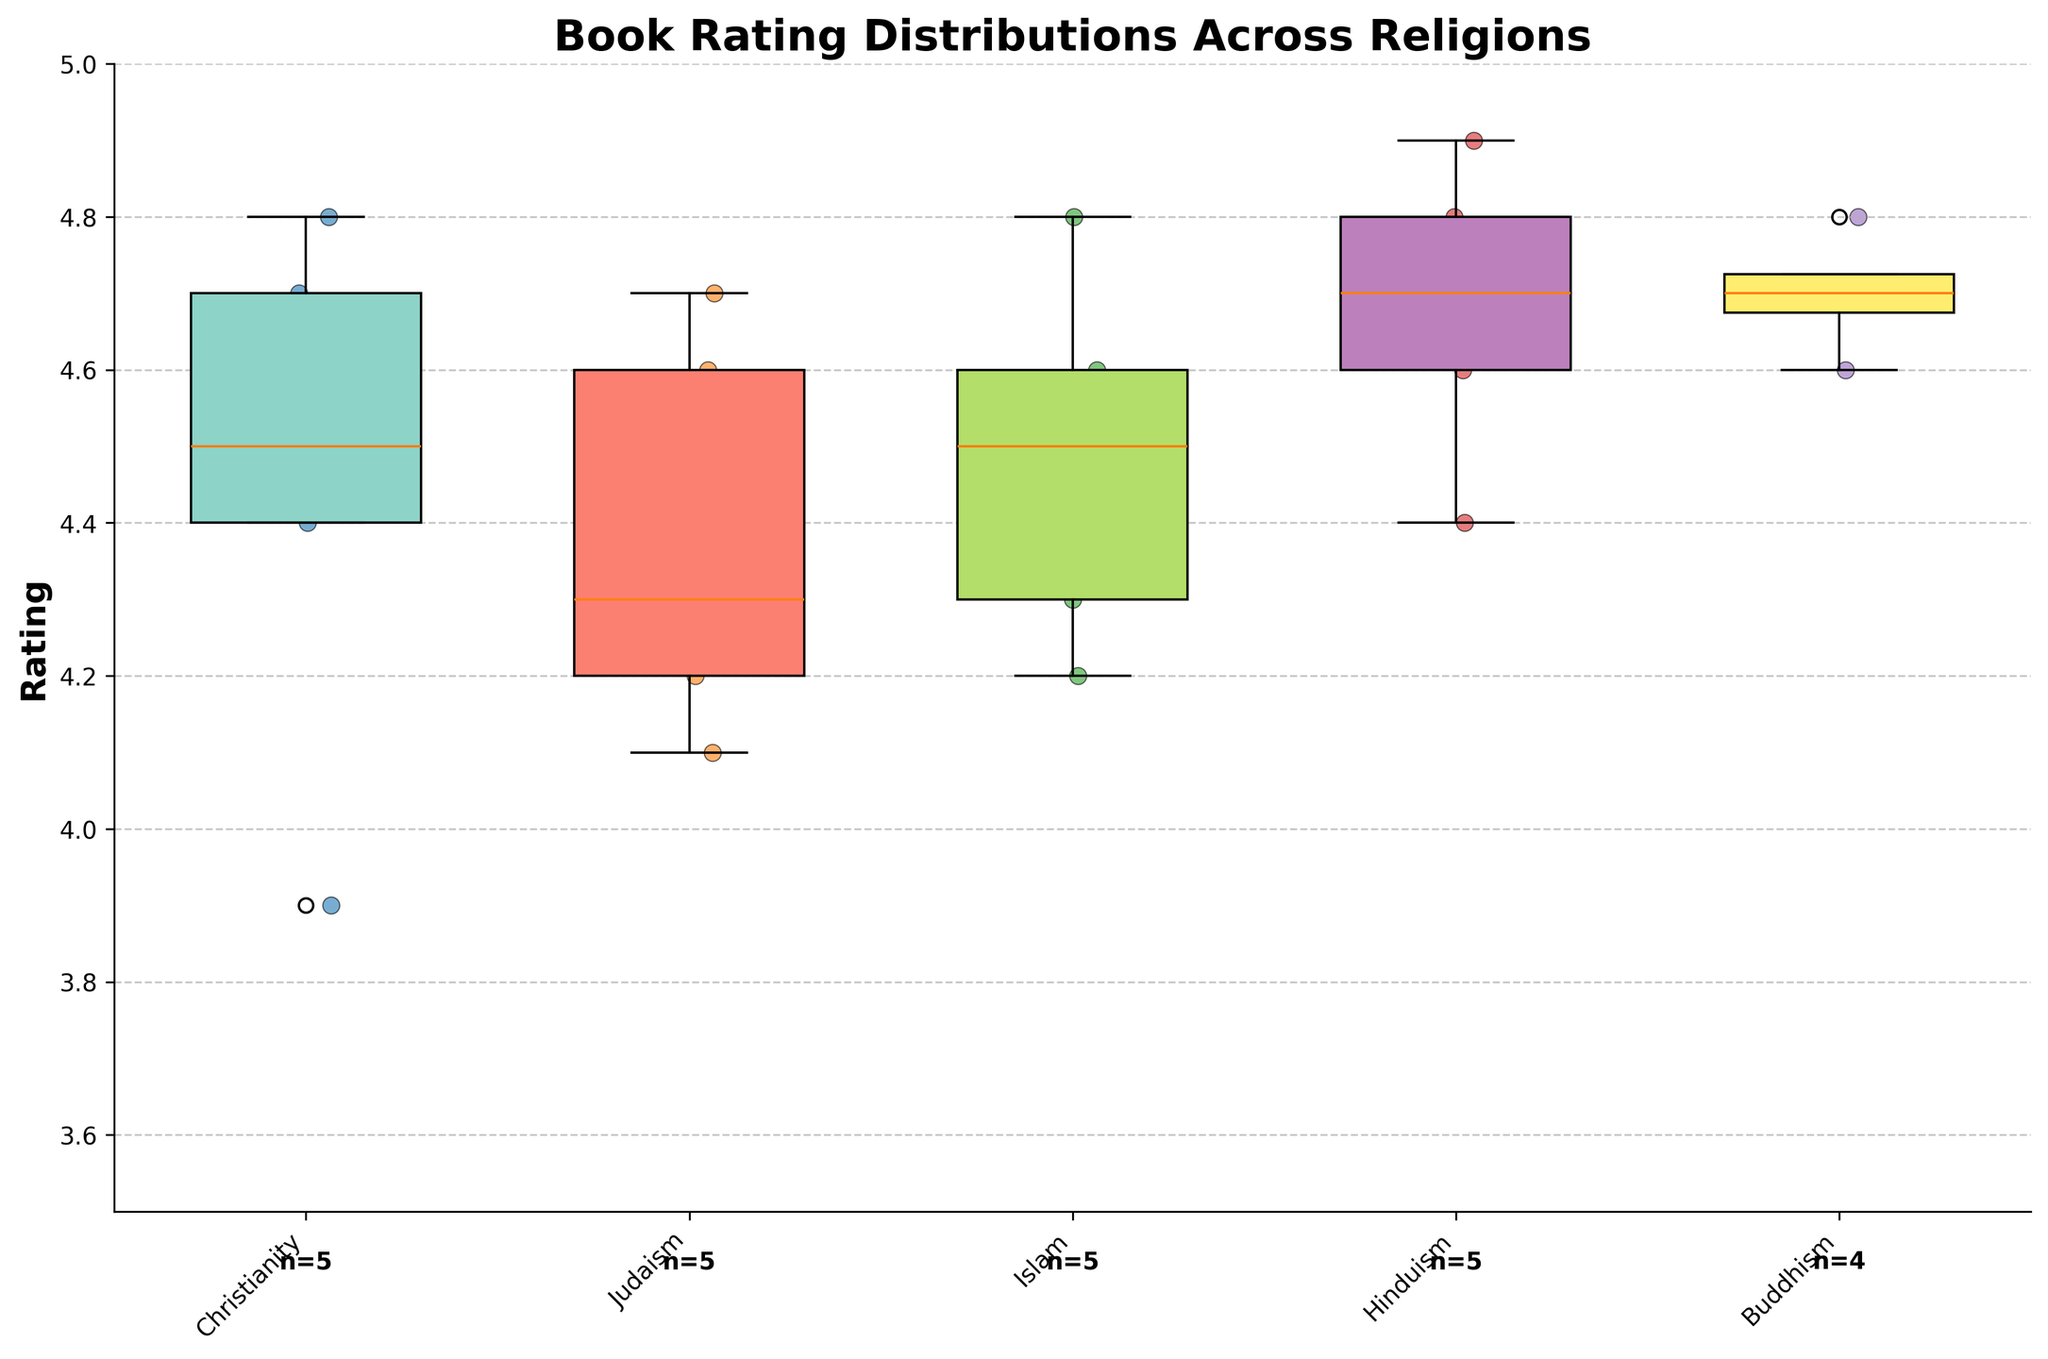How many different religions' book ratings are represented in the figure? The x-axis of the figure shows the different religions represented. Counting these religions will give us the number.
Answer: 5 Which religion has the highest median book rating? The median book rating is indicated by the line inside each box in the box plot. By comparing these lines, we can identify the religion with the highest median rating.
Answer: Hinduism What is the range of book ratings for Christianity? The range is found by noting the upper and lower whiskers of the box plot for Christianity. The range is the difference between these two values.
Answer: 4.8 - 3.9 How many books are rated from the Islamic religion? The count of data points for Islam is noted next to the label "Islam" near the x-axis. This number indicates how many books are rated.
Answer: 5 Which religions have at least one book rating above 4.6? Scatter points above 4.6 on the y-axis represent book ratings for different religions. Identifying these points and matching them to their respective religions will provide the answer.
Answer: Christianity, Judaism, Islam, Hinduism, Buddhism Which religion has the narrowest interquartile range (IQR) for its book ratings? The IQR is the distance between the top (Q3) and bottom (Q1) of the box in each box plot. By visually comparing the IQRs, we can determine the narrowest one.
Answer: Buddhism Compare the median book rating of Judaism with Buddhism. Which is higher? The median is represented by the line inside the boxes. By comparing the medians for Judaism and Buddhism, we can find which one is higher.
Answer: Both are equal Which religion has the highest variability in its book ratings and how can you tell? The variability in book ratings is indicated by the length of the whiskers and the spread of the scatter points. The longer the whiskers and wider the spread, the higher the variability.
Answer: Christianity What is the mean book rating for Hinduism? To find the mean, sum up the ratings for all books in Hinduism and divide by the number of books. The data points show ratings: 4.9, 4.7, 4.6, 4.8, 4.4. The sum is 4.9 + 4.7 + 4.6 + 4.8 + 4.4 = 23.4, and there are 5 books. So, the mean is 23.4 / 5.
Answer: 4.68 